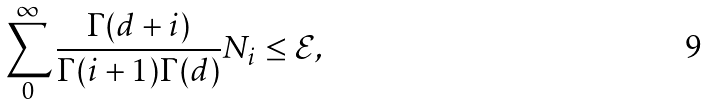Convert formula to latex. <formula><loc_0><loc_0><loc_500><loc_500>\sum _ { 0 } ^ { \infty } \frac { \Gamma ( d + i ) } { \Gamma ( i + 1 ) \Gamma ( d ) } N _ { i } \leq { \mathcal { E } } ,</formula> 